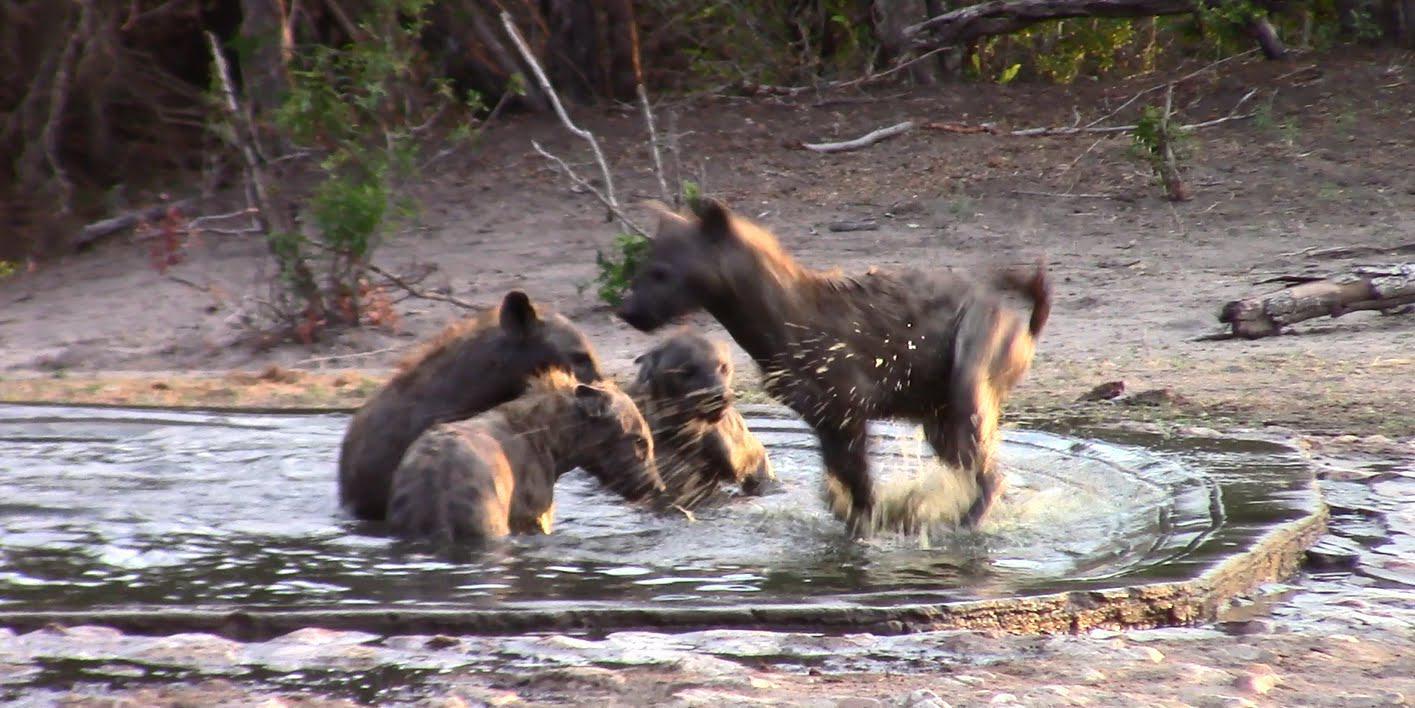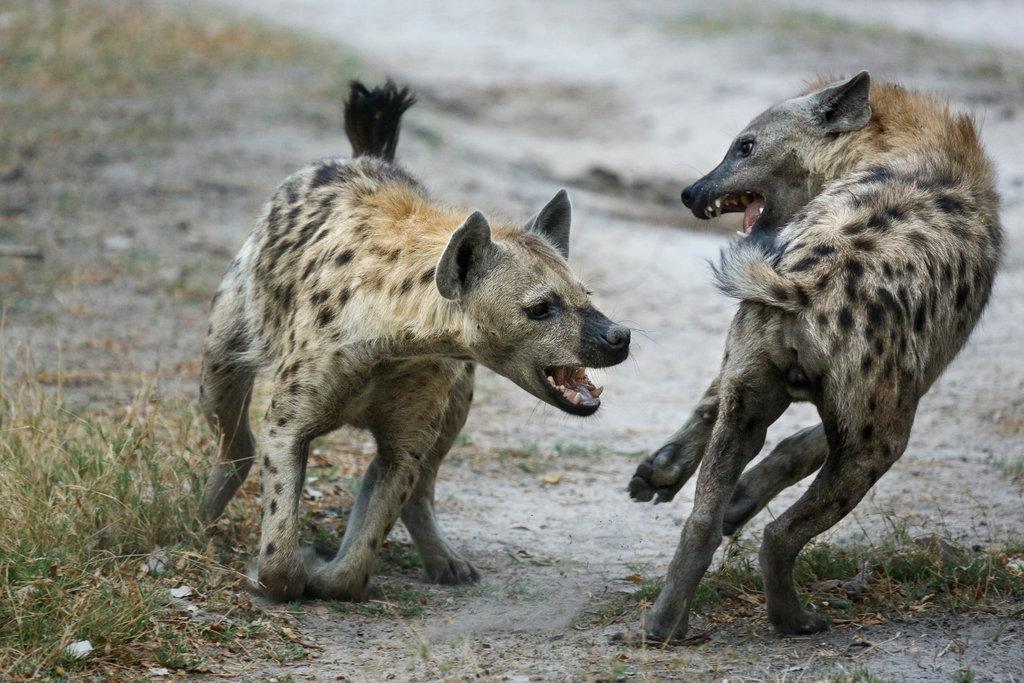The first image is the image on the left, the second image is the image on the right. For the images shown, is this caption "The left image contains one adult hyena and one baby hyena." true? Answer yes or no. No. The first image is the image on the left, the second image is the image on the right. Assess this claim about the two images: "Exactly one of the images shows hyenas in a wet area.". Correct or not? Answer yes or no. Yes. 